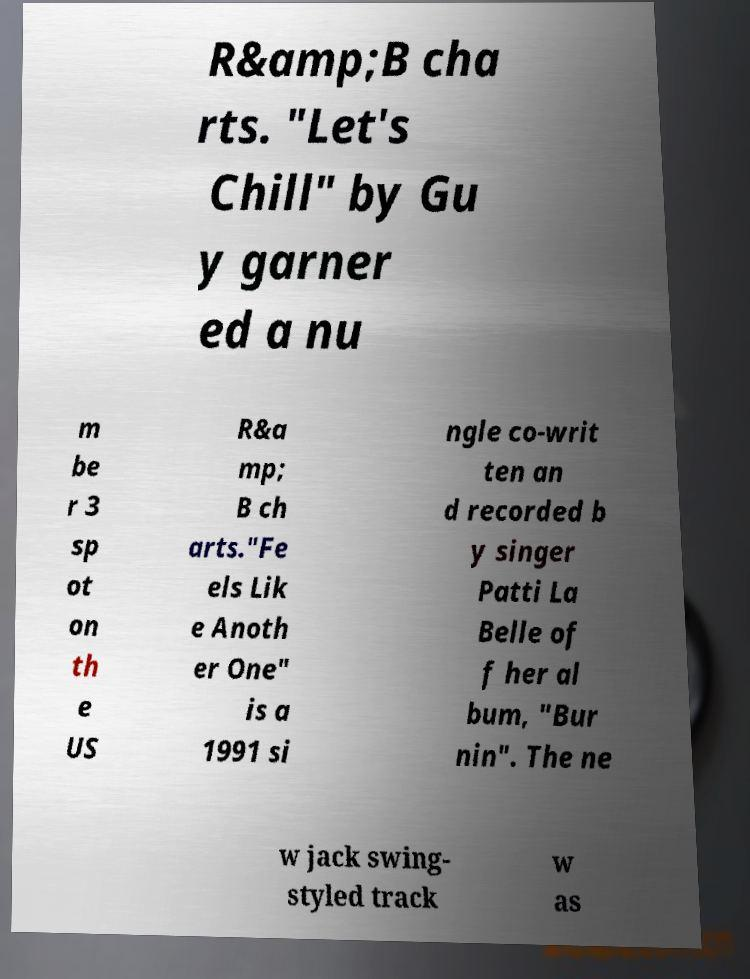Could you assist in decoding the text presented in this image and type it out clearly? R&amp;B cha rts. "Let's Chill" by Gu y garner ed a nu m be r 3 sp ot on th e US R&a mp; B ch arts."Fe els Lik e Anoth er One" is a 1991 si ngle co-writ ten an d recorded b y singer Patti La Belle of f her al bum, "Bur nin". The ne w jack swing- styled track w as 